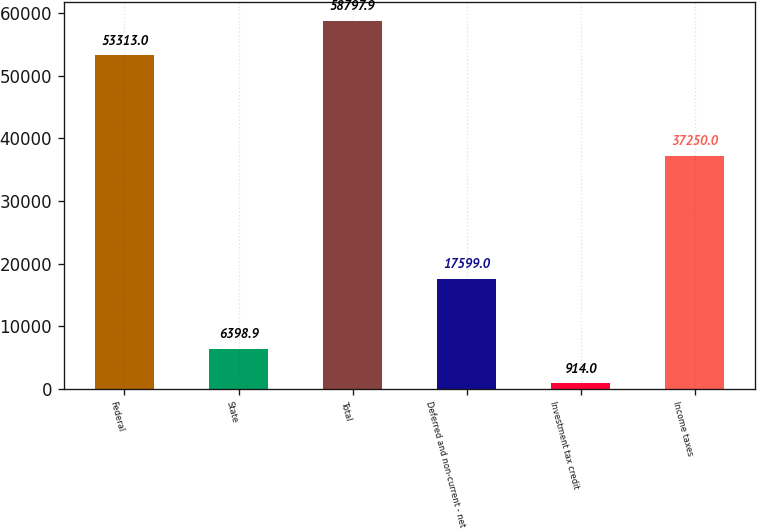<chart> <loc_0><loc_0><loc_500><loc_500><bar_chart><fcel>Federal<fcel>State<fcel>Total<fcel>Deferred and non-current - net<fcel>Investment tax credit<fcel>Income taxes<nl><fcel>53313<fcel>6398.9<fcel>58797.9<fcel>17599<fcel>914<fcel>37250<nl></chart> 